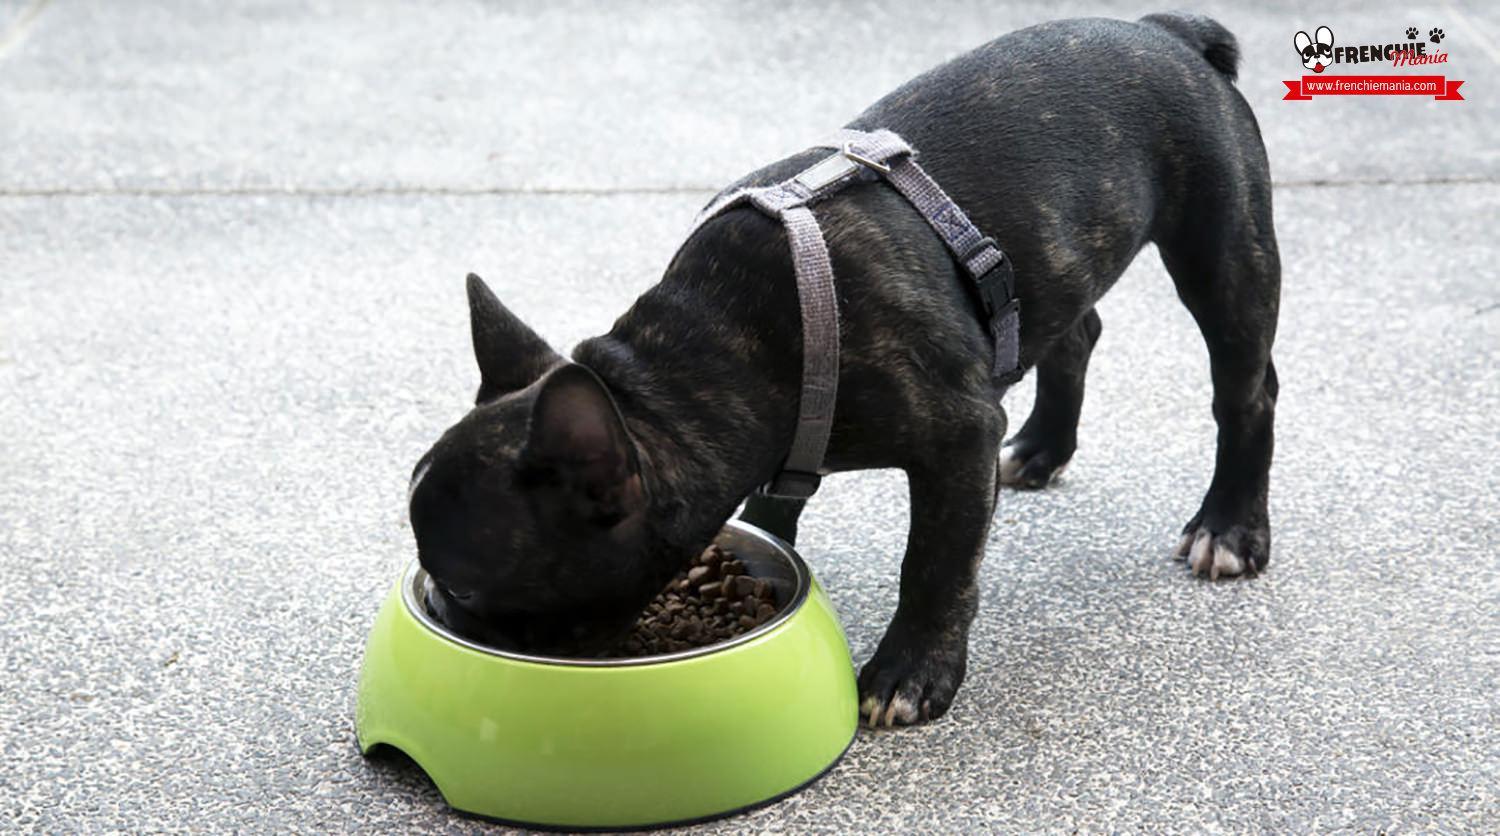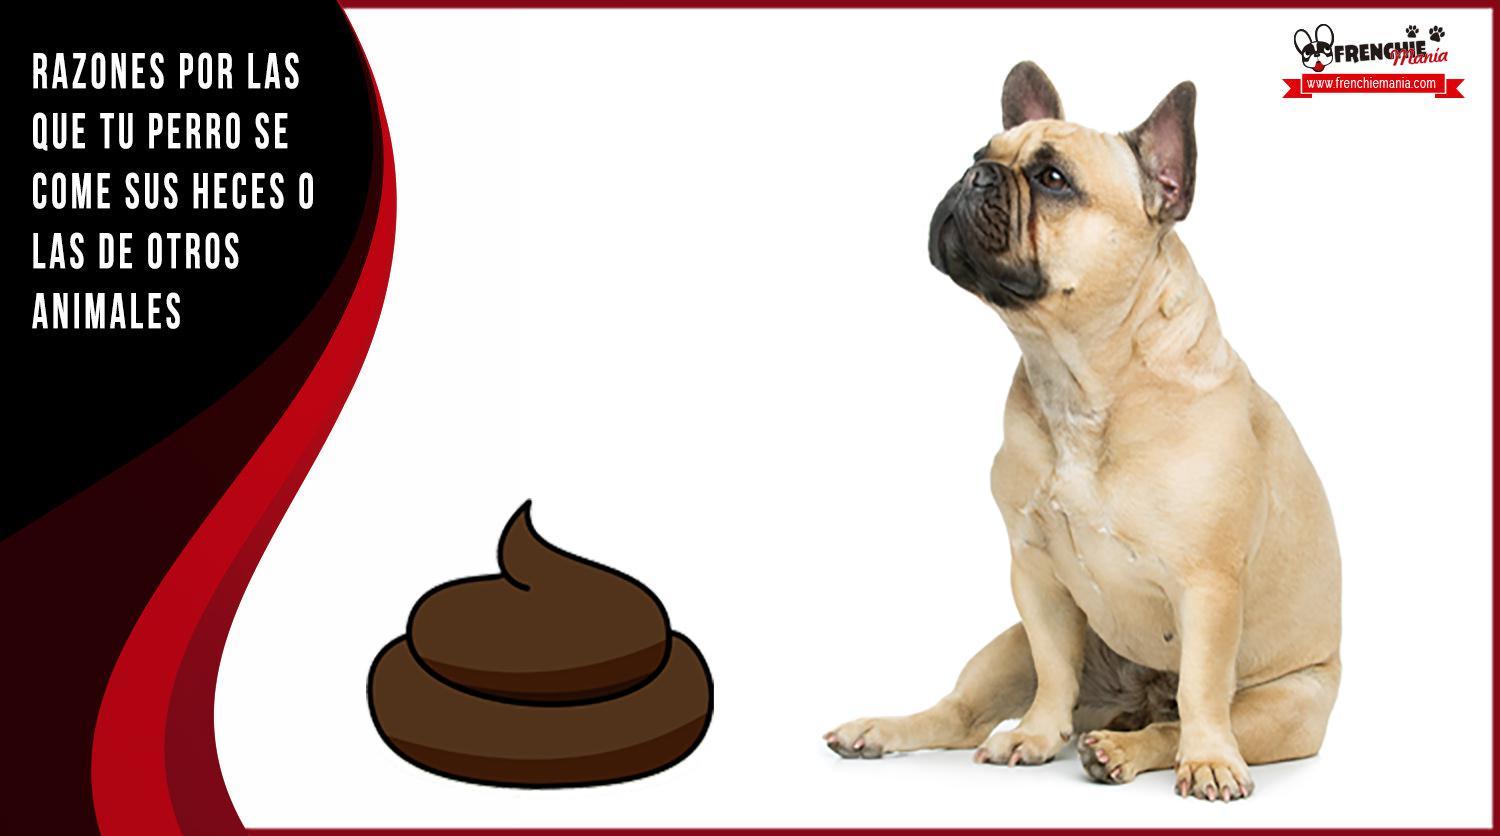The first image is the image on the left, the second image is the image on the right. Assess this claim about the two images: "One image in the pair shows at least one dog eating.". Correct or not? Answer yes or no. Yes. The first image is the image on the left, the second image is the image on the right. Given the left and right images, does the statement "One image features a french bulldog wearing a checkered napkin around its neck, and the other image includes a silver-colored dog food bowl and at least one bulldog." hold true? Answer yes or no. No. 